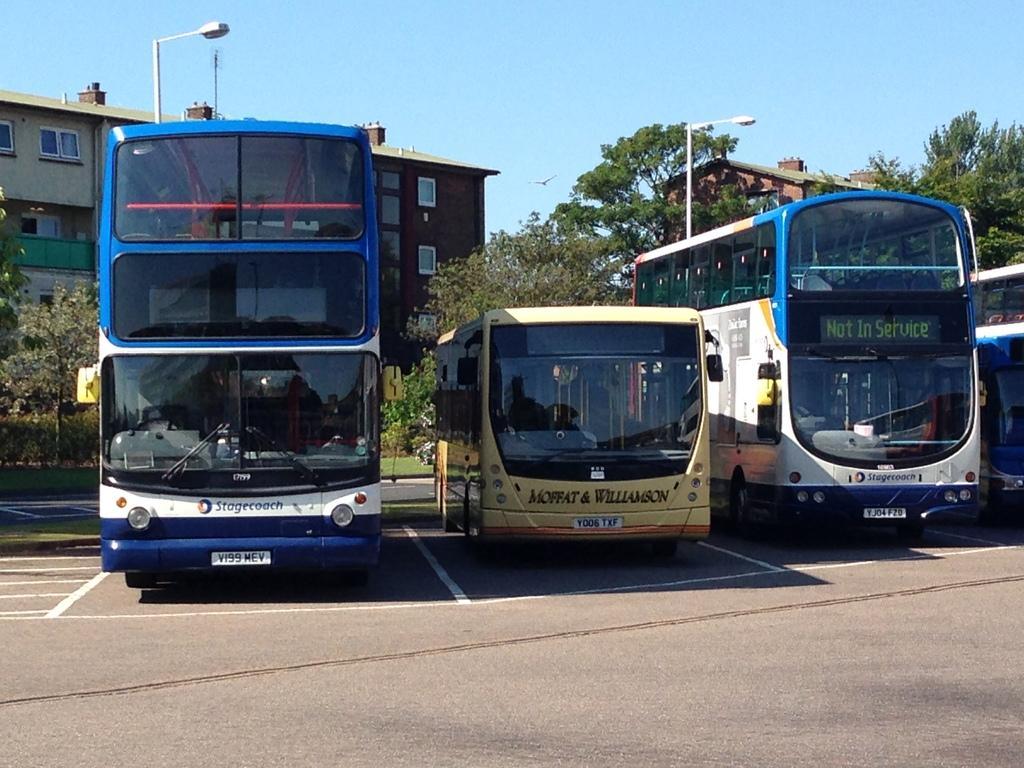In one or two sentences, can you explain what this image depicts? This is an outside view. Here I can see few buses on the road. In the background there are some buildings, trees and light poles. At the top of the image I can see the sky. 